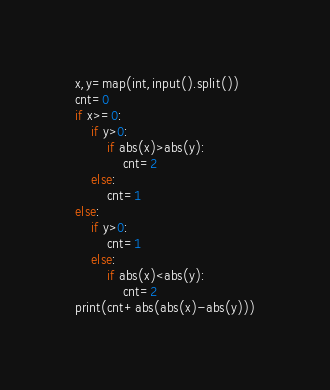<code> <loc_0><loc_0><loc_500><loc_500><_Python_>x,y=map(int,input().split())
cnt=0
if x>=0:
    if y>0:
        if abs(x)>abs(y):
            cnt=2
    else:
        cnt=1
else:
    if y>0:
        cnt=1
    else:
        if abs(x)<abs(y):
            cnt=2
print(cnt+abs(abs(x)-abs(y)))
</code> 